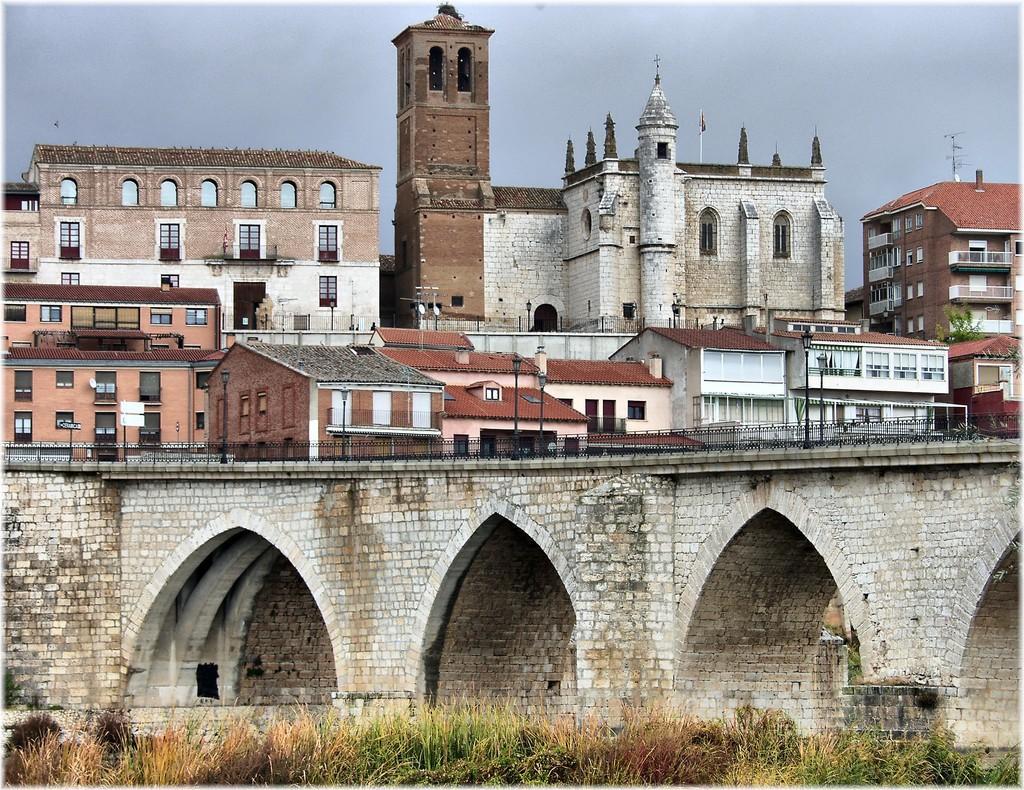Could you give a brief overview of what you see in this image? In this picture we can see planets, bridge, buildings with windows, some objects and in the background we can see the sky. 